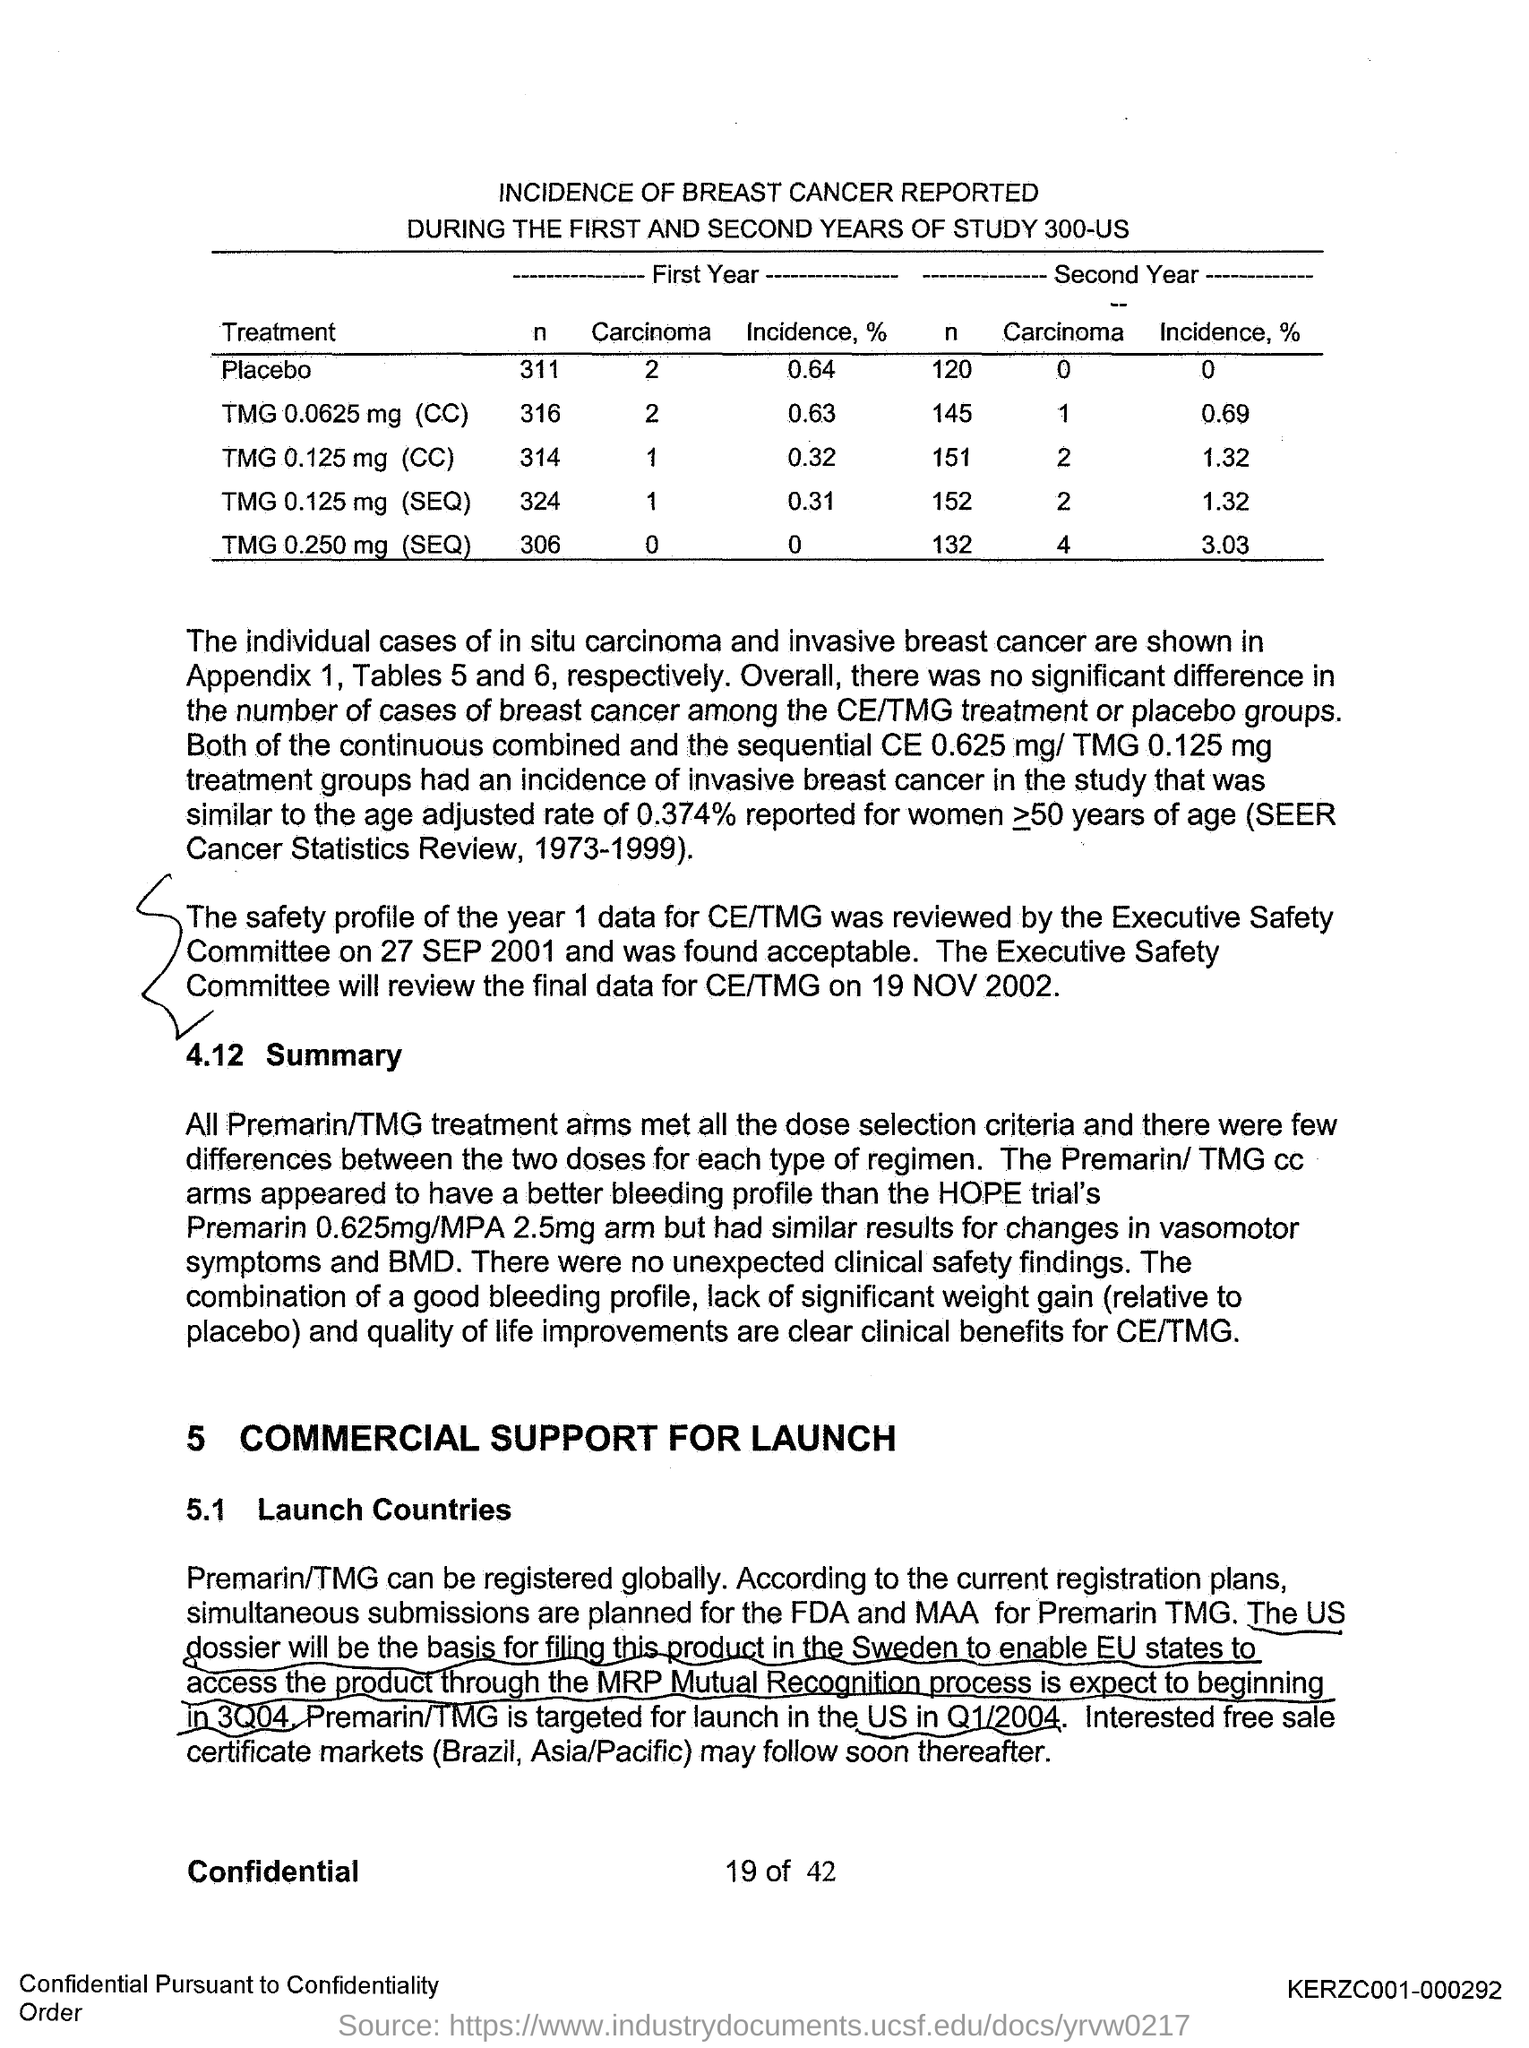Number of people undergone placebo treatment during the first year?
Your response must be concise. 311. Number of people undergone placebo treatment during the second year?
Ensure brevity in your answer.  120. 